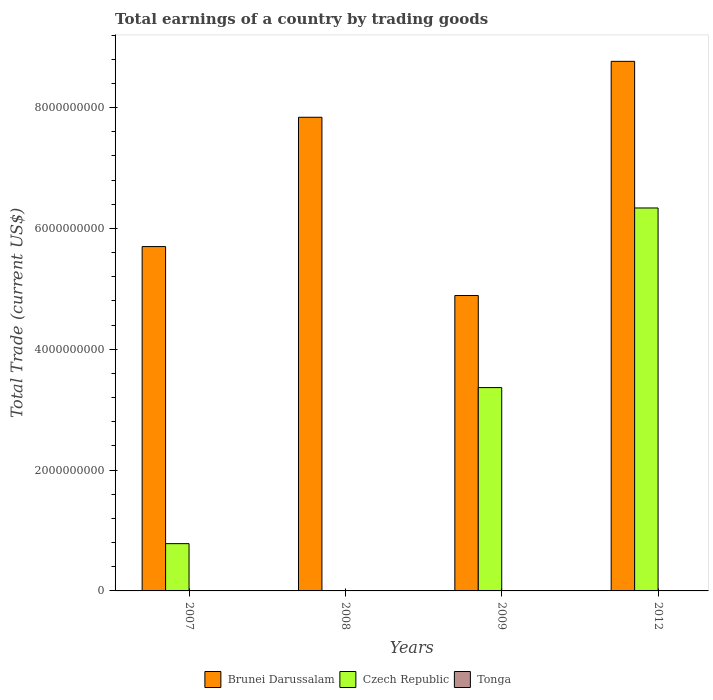How many different coloured bars are there?
Provide a short and direct response. 2. Are the number of bars on each tick of the X-axis equal?
Keep it short and to the point. No. How many bars are there on the 1st tick from the right?
Make the answer very short. 2. What is the total earnings in Tonga in 2007?
Keep it short and to the point. 0. Across all years, what is the maximum total earnings in Czech Republic?
Offer a terse response. 6.34e+09. Across all years, what is the minimum total earnings in Brunei Darussalam?
Your response must be concise. 4.89e+09. In which year was the total earnings in Czech Republic maximum?
Provide a short and direct response. 2012. What is the total total earnings in Tonga in the graph?
Your response must be concise. 0. What is the difference between the total earnings in Czech Republic in 2009 and that in 2012?
Provide a short and direct response. -2.97e+09. What is the difference between the total earnings in Tonga in 2008 and the total earnings in Czech Republic in 2012?
Ensure brevity in your answer.  -6.34e+09. What is the average total earnings in Tonga per year?
Your answer should be compact. 0. In the year 2007, what is the difference between the total earnings in Brunei Darussalam and total earnings in Czech Republic?
Your response must be concise. 4.92e+09. What is the ratio of the total earnings in Czech Republic in 2007 to that in 2009?
Your response must be concise. 0.23. Is the total earnings in Czech Republic in 2009 less than that in 2012?
Provide a succinct answer. Yes. Is the difference between the total earnings in Brunei Darussalam in 2009 and 2012 greater than the difference between the total earnings in Czech Republic in 2009 and 2012?
Offer a very short reply. No. What is the difference between the highest and the second highest total earnings in Czech Republic?
Your response must be concise. 2.97e+09. What is the difference between the highest and the lowest total earnings in Brunei Darussalam?
Offer a very short reply. 3.88e+09. In how many years, is the total earnings in Czech Republic greater than the average total earnings in Czech Republic taken over all years?
Make the answer very short. 2. Is the sum of the total earnings in Czech Republic in 2007 and 2012 greater than the maximum total earnings in Tonga across all years?
Your response must be concise. Yes. Are all the bars in the graph horizontal?
Give a very brief answer. No. What is the difference between two consecutive major ticks on the Y-axis?
Provide a succinct answer. 2.00e+09. Does the graph contain any zero values?
Your response must be concise. Yes. Does the graph contain grids?
Make the answer very short. No. Where does the legend appear in the graph?
Your answer should be very brief. Bottom center. What is the title of the graph?
Keep it short and to the point. Total earnings of a country by trading goods. Does "Cambodia" appear as one of the legend labels in the graph?
Your answer should be compact. No. What is the label or title of the X-axis?
Your answer should be very brief. Years. What is the label or title of the Y-axis?
Give a very brief answer. Total Trade (current US$). What is the Total Trade (current US$) of Brunei Darussalam in 2007?
Make the answer very short. 5.70e+09. What is the Total Trade (current US$) of Czech Republic in 2007?
Offer a terse response. 7.83e+08. What is the Total Trade (current US$) of Brunei Darussalam in 2008?
Your answer should be very brief. 7.84e+09. What is the Total Trade (current US$) of Brunei Darussalam in 2009?
Provide a short and direct response. 4.89e+09. What is the Total Trade (current US$) in Czech Republic in 2009?
Give a very brief answer. 3.37e+09. What is the Total Trade (current US$) in Tonga in 2009?
Your answer should be very brief. 0. What is the Total Trade (current US$) of Brunei Darussalam in 2012?
Keep it short and to the point. 8.77e+09. What is the Total Trade (current US$) of Czech Republic in 2012?
Offer a very short reply. 6.34e+09. What is the Total Trade (current US$) of Tonga in 2012?
Provide a short and direct response. 0. Across all years, what is the maximum Total Trade (current US$) of Brunei Darussalam?
Provide a short and direct response. 8.77e+09. Across all years, what is the maximum Total Trade (current US$) of Czech Republic?
Keep it short and to the point. 6.34e+09. Across all years, what is the minimum Total Trade (current US$) of Brunei Darussalam?
Make the answer very short. 4.89e+09. What is the total Total Trade (current US$) in Brunei Darussalam in the graph?
Your answer should be very brief. 2.72e+1. What is the total Total Trade (current US$) in Czech Republic in the graph?
Make the answer very short. 1.05e+1. What is the total Total Trade (current US$) of Tonga in the graph?
Offer a terse response. 0. What is the difference between the Total Trade (current US$) of Brunei Darussalam in 2007 and that in 2008?
Your response must be concise. -2.14e+09. What is the difference between the Total Trade (current US$) in Brunei Darussalam in 2007 and that in 2009?
Ensure brevity in your answer.  8.10e+08. What is the difference between the Total Trade (current US$) in Czech Republic in 2007 and that in 2009?
Keep it short and to the point. -2.58e+09. What is the difference between the Total Trade (current US$) of Brunei Darussalam in 2007 and that in 2012?
Provide a succinct answer. -3.07e+09. What is the difference between the Total Trade (current US$) in Czech Republic in 2007 and that in 2012?
Keep it short and to the point. -5.56e+09. What is the difference between the Total Trade (current US$) in Brunei Darussalam in 2008 and that in 2009?
Your answer should be very brief. 2.95e+09. What is the difference between the Total Trade (current US$) in Brunei Darussalam in 2008 and that in 2012?
Provide a succinct answer. -9.26e+08. What is the difference between the Total Trade (current US$) of Brunei Darussalam in 2009 and that in 2012?
Provide a succinct answer. -3.88e+09. What is the difference between the Total Trade (current US$) in Czech Republic in 2009 and that in 2012?
Ensure brevity in your answer.  -2.97e+09. What is the difference between the Total Trade (current US$) in Brunei Darussalam in 2007 and the Total Trade (current US$) in Czech Republic in 2009?
Keep it short and to the point. 2.33e+09. What is the difference between the Total Trade (current US$) of Brunei Darussalam in 2007 and the Total Trade (current US$) of Czech Republic in 2012?
Provide a short and direct response. -6.39e+08. What is the difference between the Total Trade (current US$) of Brunei Darussalam in 2008 and the Total Trade (current US$) of Czech Republic in 2009?
Provide a short and direct response. 4.47e+09. What is the difference between the Total Trade (current US$) in Brunei Darussalam in 2008 and the Total Trade (current US$) in Czech Republic in 2012?
Provide a succinct answer. 1.50e+09. What is the difference between the Total Trade (current US$) of Brunei Darussalam in 2009 and the Total Trade (current US$) of Czech Republic in 2012?
Keep it short and to the point. -1.45e+09. What is the average Total Trade (current US$) in Brunei Darussalam per year?
Offer a very short reply. 6.80e+09. What is the average Total Trade (current US$) of Czech Republic per year?
Ensure brevity in your answer.  2.62e+09. What is the average Total Trade (current US$) of Tonga per year?
Offer a very short reply. 0. In the year 2007, what is the difference between the Total Trade (current US$) in Brunei Darussalam and Total Trade (current US$) in Czech Republic?
Provide a succinct answer. 4.92e+09. In the year 2009, what is the difference between the Total Trade (current US$) in Brunei Darussalam and Total Trade (current US$) in Czech Republic?
Give a very brief answer. 1.52e+09. In the year 2012, what is the difference between the Total Trade (current US$) of Brunei Darussalam and Total Trade (current US$) of Czech Republic?
Give a very brief answer. 2.43e+09. What is the ratio of the Total Trade (current US$) of Brunei Darussalam in 2007 to that in 2008?
Give a very brief answer. 0.73. What is the ratio of the Total Trade (current US$) in Brunei Darussalam in 2007 to that in 2009?
Your response must be concise. 1.17. What is the ratio of the Total Trade (current US$) in Czech Republic in 2007 to that in 2009?
Your answer should be compact. 0.23. What is the ratio of the Total Trade (current US$) in Brunei Darussalam in 2007 to that in 2012?
Your answer should be very brief. 0.65. What is the ratio of the Total Trade (current US$) in Czech Republic in 2007 to that in 2012?
Provide a succinct answer. 0.12. What is the ratio of the Total Trade (current US$) in Brunei Darussalam in 2008 to that in 2009?
Offer a very short reply. 1.6. What is the ratio of the Total Trade (current US$) in Brunei Darussalam in 2008 to that in 2012?
Provide a short and direct response. 0.89. What is the ratio of the Total Trade (current US$) of Brunei Darussalam in 2009 to that in 2012?
Ensure brevity in your answer.  0.56. What is the ratio of the Total Trade (current US$) in Czech Republic in 2009 to that in 2012?
Offer a very short reply. 0.53. What is the difference between the highest and the second highest Total Trade (current US$) of Brunei Darussalam?
Make the answer very short. 9.26e+08. What is the difference between the highest and the second highest Total Trade (current US$) in Czech Republic?
Give a very brief answer. 2.97e+09. What is the difference between the highest and the lowest Total Trade (current US$) in Brunei Darussalam?
Provide a succinct answer. 3.88e+09. What is the difference between the highest and the lowest Total Trade (current US$) in Czech Republic?
Ensure brevity in your answer.  6.34e+09. 